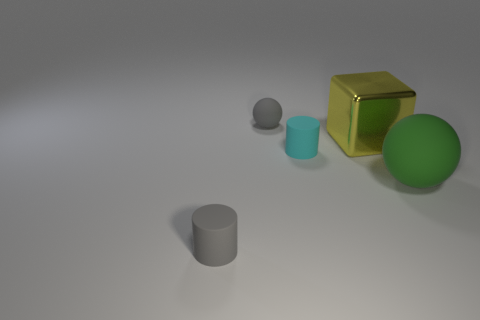Add 5 tiny yellow metal spheres. How many objects exist? 10 Subtract all blocks. How many objects are left? 4 Add 1 large rubber spheres. How many large rubber spheres are left? 2 Add 1 cyan cylinders. How many cyan cylinders exist? 2 Subtract 1 green balls. How many objects are left? 4 Subtract all blue blocks. Subtract all big metal objects. How many objects are left? 4 